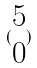Convert formula to latex. <formula><loc_0><loc_0><loc_500><loc_500>( \begin{matrix} 5 \\ 0 \end{matrix} )</formula> 